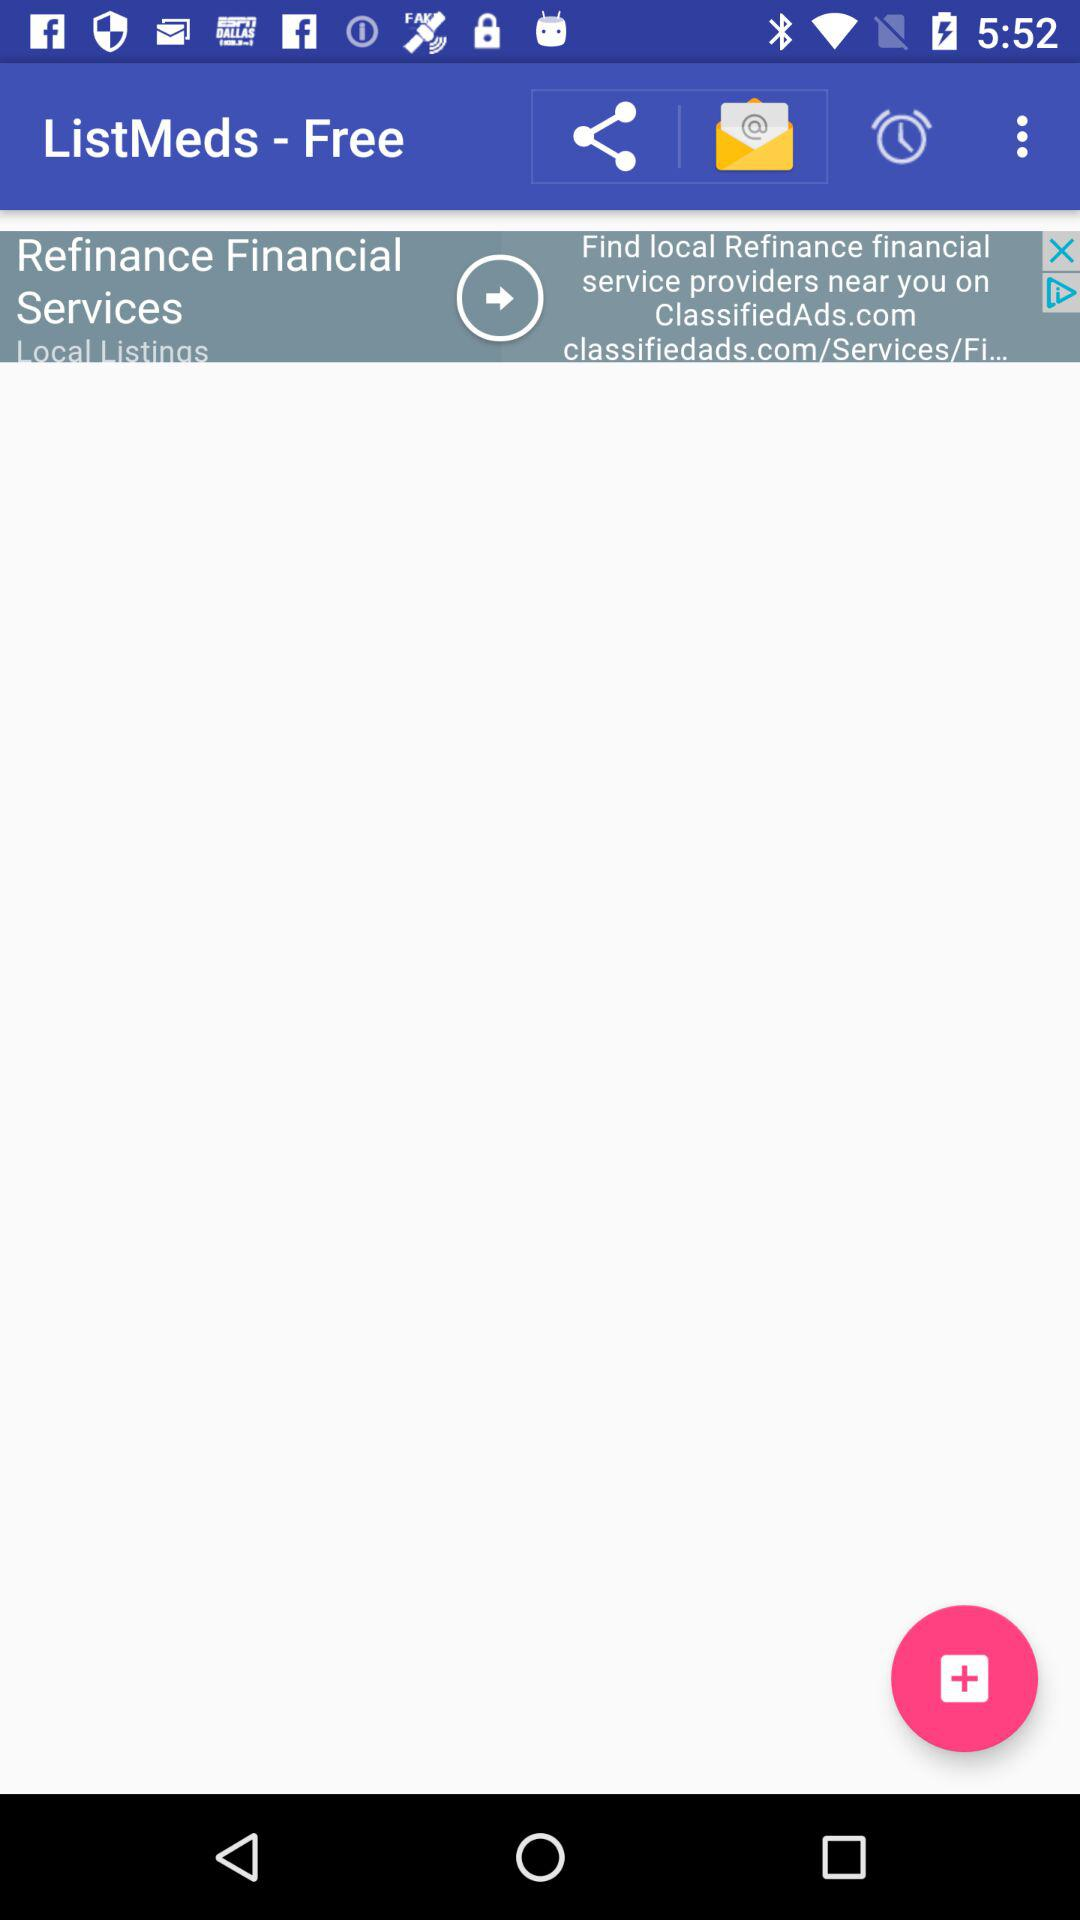What is the name of the application? The application name is "ListMeds-Free". 